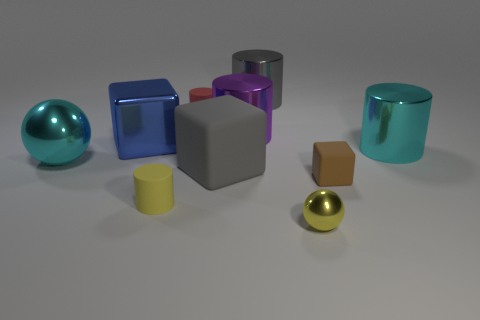What number of purple things are tiny shiny balls or large rubber things?
Provide a succinct answer. 0. There is a big cyan thing that is behind the large cyan sphere; what is its material?
Give a very brief answer. Metal. Is the number of large metal things greater than the number of cyan objects?
Make the answer very short. Yes. There is a tiny object on the right side of the small yellow sphere; is it the same shape as the big purple thing?
Make the answer very short. No. What number of cubes are both behind the brown object and right of the small yellow rubber cylinder?
Provide a succinct answer. 1. What number of gray shiny objects have the same shape as the large matte object?
Your response must be concise. 0. There is a big cube that is behind the cyan metal object to the right of the purple shiny thing; what color is it?
Ensure brevity in your answer.  Blue. There is a yellow metal object; is its shape the same as the tiny matte thing that is to the right of the large gray rubber block?
Offer a very short reply. No. What is the material of the big gray thing behind the tiny thing behind the cyan shiny thing to the left of the yellow sphere?
Give a very brief answer. Metal. Are there any cylinders that have the same size as the brown object?
Keep it short and to the point. Yes. 